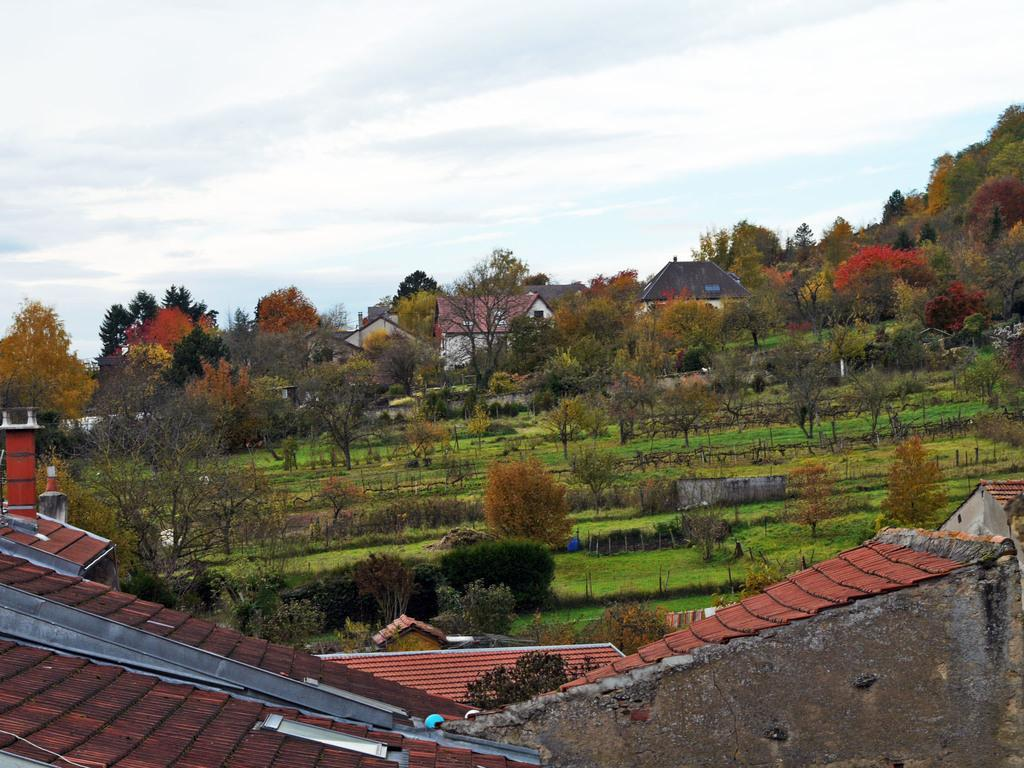What type of structures can be seen in the image? There are buildings in the image. What other natural elements are present in the image? There are trees in the image. What is visible in the background of the image? The sky is visible in the image. What type of ground surface is at the bottom of the image? There is grass on the surface at the bottom of the image. What holiday is being celebrated in the image? There is no indication of a holiday being celebrated in the image. What type of crime is being committed in the image? There is no crime being committed in the image; it features buildings, trees, sky, and grass. 